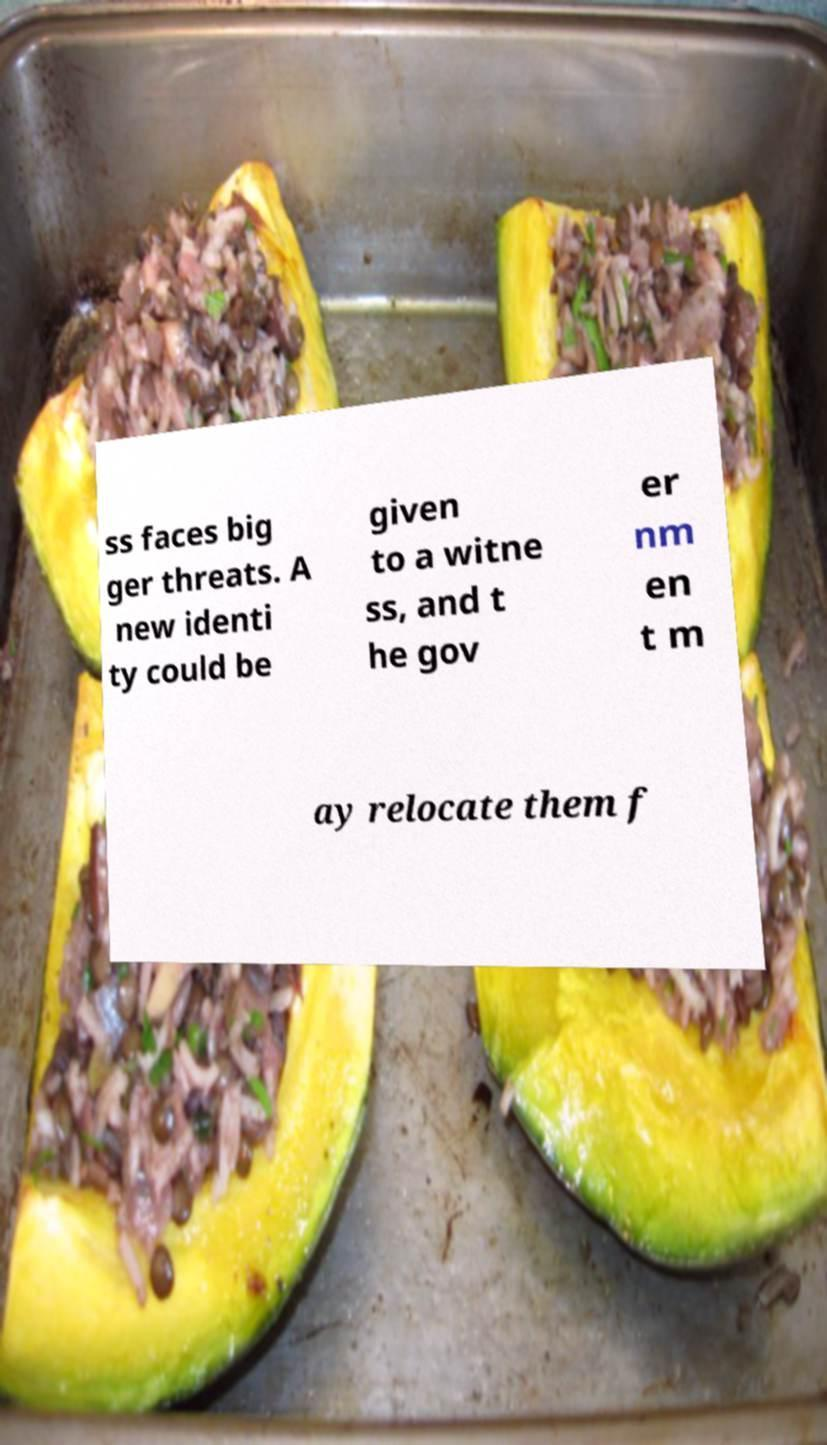For documentation purposes, I need the text within this image transcribed. Could you provide that? ss faces big ger threats. A new identi ty could be given to a witne ss, and t he gov er nm en t m ay relocate them f 